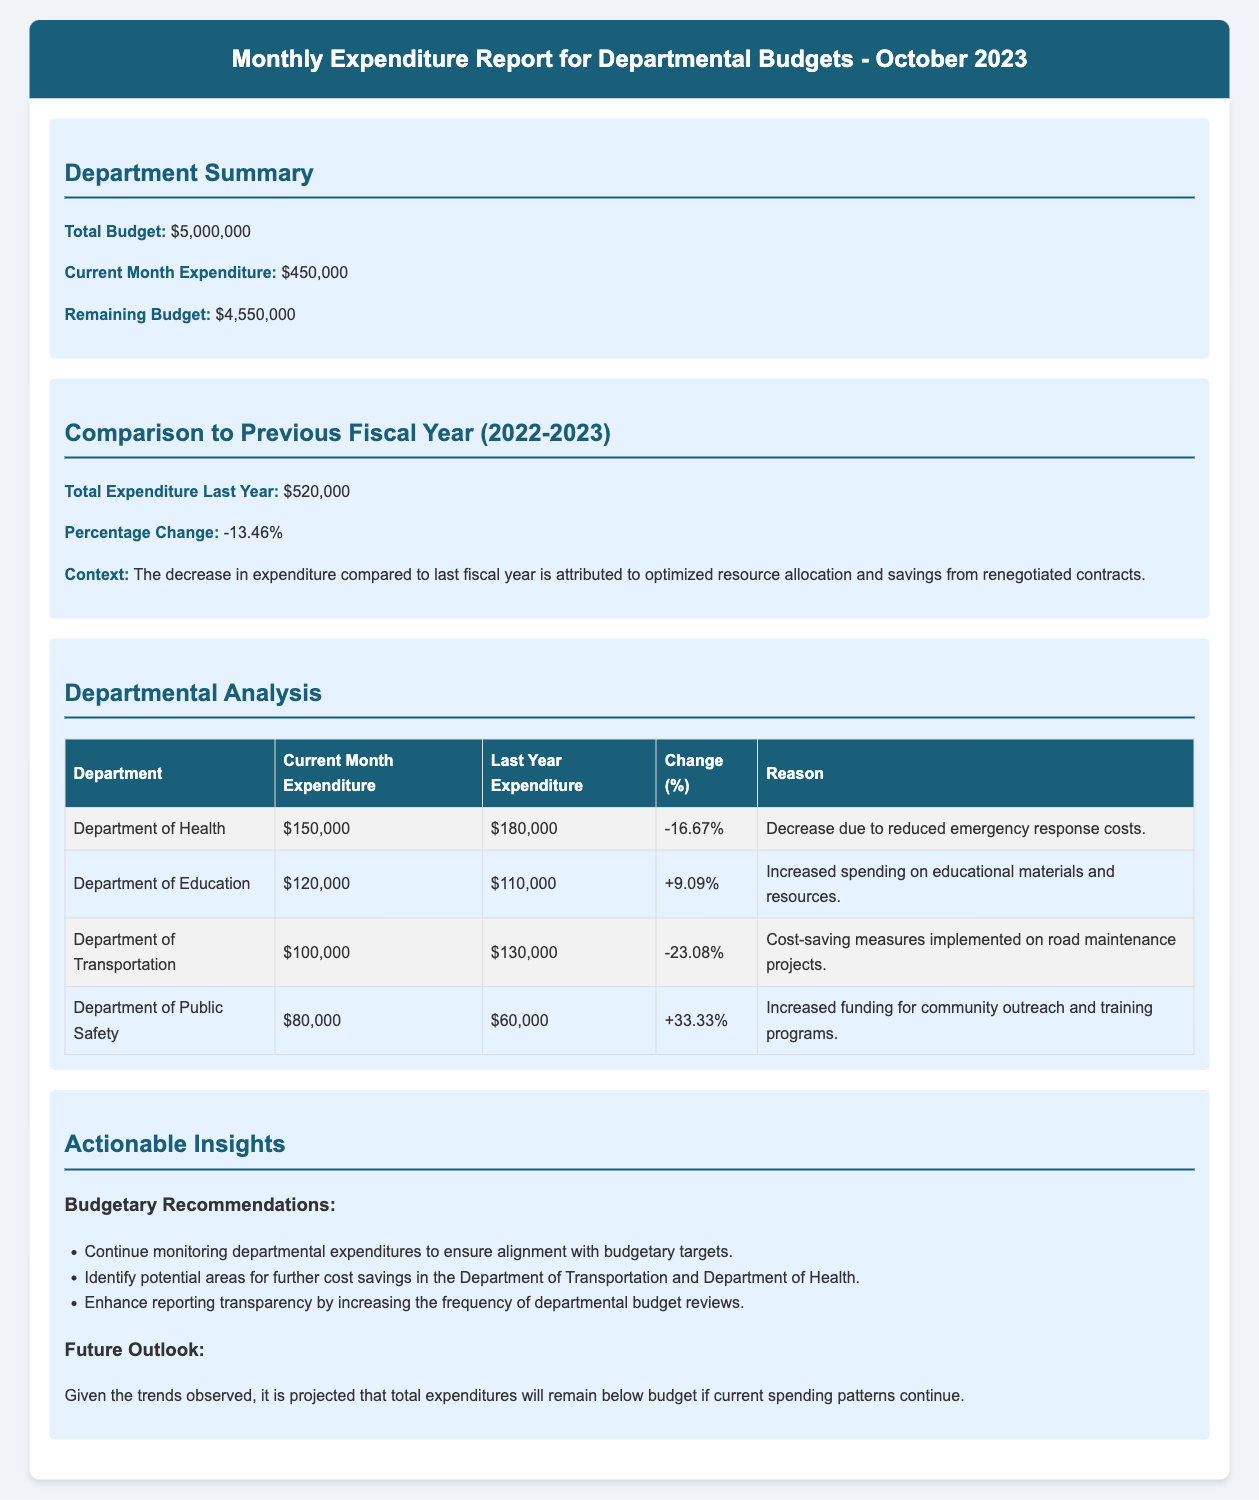What is the total budget? The total budget for departmental expenditures is stated in the report.
Answer: $5,000,000 What was the current month expenditure? The report specifies the current month’s expenditure amount directly.
Answer: $450,000 What is the remaining budget? The remaining budget can be calculated from the total budget and current month expenditure provided in the document.
Answer: $4,550,000 What was the total expenditure last year? The report compares the current month’s expenditure to the previous fiscal year.
Answer: $520,000 What percentage change is noted in the report? The document clearly states the percentage change in expenditures compared to the previous fiscal year.
Answer: -13.46% Which department had the largest increase in expenditure? The table shows the departmental analysis including their respective percentage changes.
Answer: Department of Public Safety What was the decrease in expenditure for the Department of Health? The report includes specific percentage changes for each department’s expenditure.
Answer: -16.67% What was the reason for the reduced expenditure in the Department of Transportation? The reasoning behind the changes in expenditures is provided for each department.
Answer: Cost-saving measures implemented on road maintenance projects What specific action is recommended for the Department of Health? The document outlines actionable insights, including recommendations for budgeting.
Answer: Identify potential areas for further cost savings 